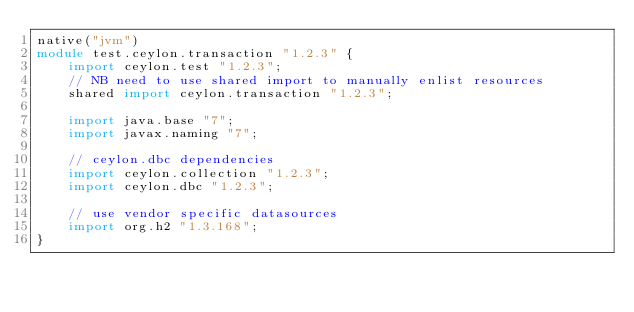<code> <loc_0><loc_0><loc_500><loc_500><_Ceylon_>native("jvm")
module test.ceylon.transaction "1.2.3" {
    import ceylon.test "1.2.3";
    // NB need to use shared import to manually enlist resources
    shared import ceylon.transaction "1.2.3";

    import java.base "7";
    import javax.naming "7";

    // ceylon.dbc dependencies
    import ceylon.collection "1.2.3";
    import ceylon.dbc "1.2.3";

    // use vendor specific datasources
    import org.h2 "1.3.168";
}
</code> 